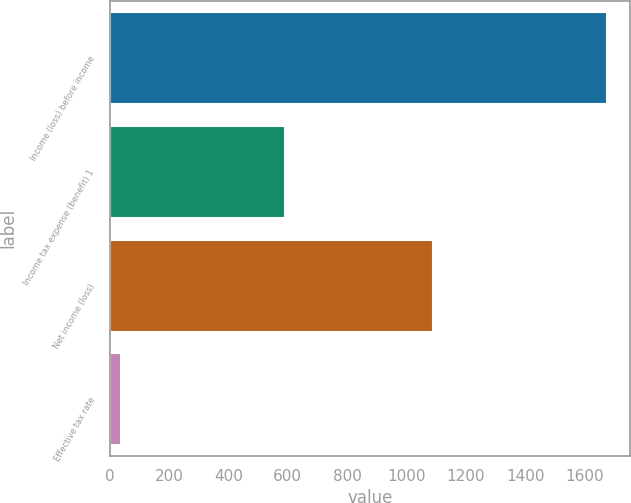Convert chart to OTSL. <chart><loc_0><loc_0><loc_500><loc_500><bar_chart><fcel>Income (loss) before income<fcel>Income tax expense (benefit) 1<fcel>Net income (loss)<fcel>Effective tax rate<nl><fcel>1671<fcel>586<fcel>1086<fcel>35<nl></chart> 